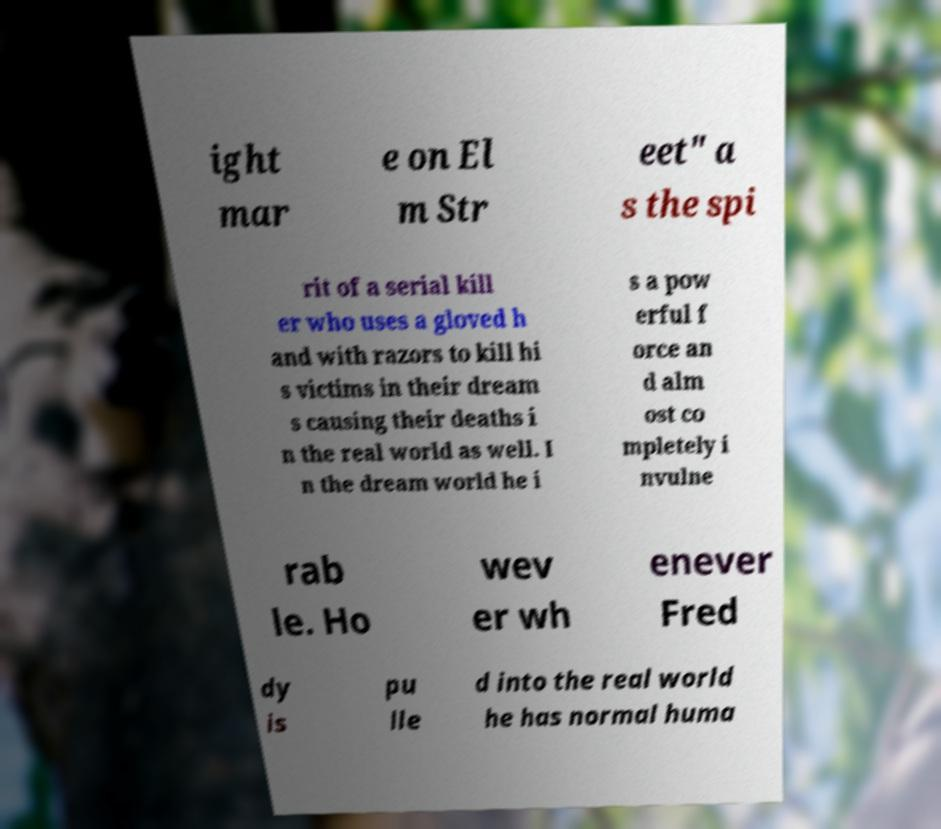What messages or text are displayed in this image? I need them in a readable, typed format. ight mar e on El m Str eet" a s the spi rit of a serial kill er who uses a gloved h and with razors to kill hi s victims in their dream s causing their deaths i n the real world as well. I n the dream world he i s a pow erful f orce an d alm ost co mpletely i nvulne rab le. Ho wev er wh enever Fred dy is pu lle d into the real world he has normal huma 